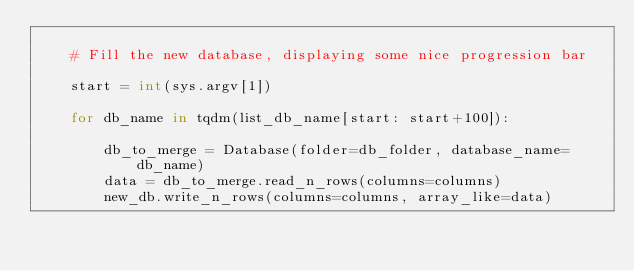Convert code to text. <code><loc_0><loc_0><loc_500><loc_500><_Python_>
    # Fill the new database, displaying some nice progression bar

    start = int(sys.argv[1])

    for db_name in tqdm(list_db_name[start: start+100]):

        db_to_merge = Database(folder=db_folder, database_name=db_name)
        data = db_to_merge.read_n_rows(columns=columns)
        new_db.write_n_rows(columns=columns, array_like=data)
</code> 